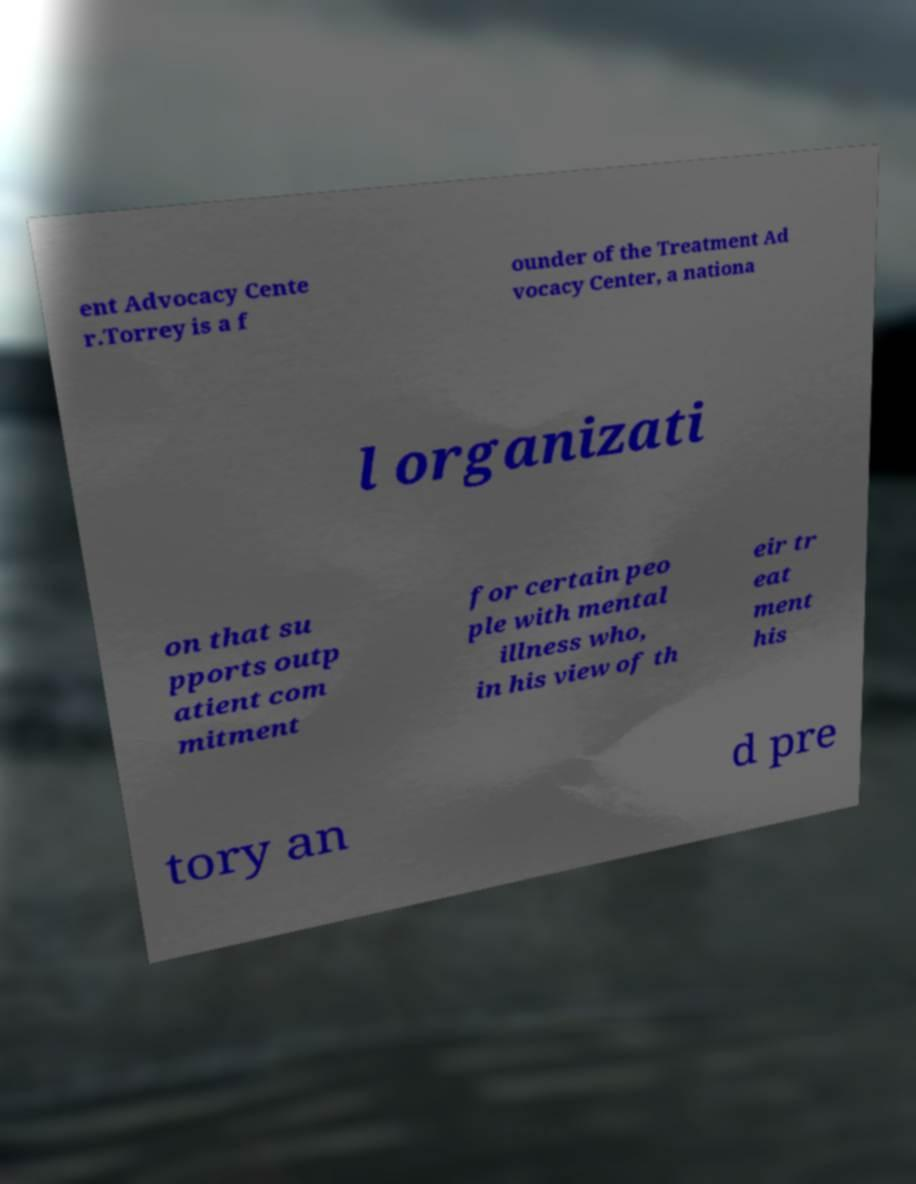Please read and relay the text visible in this image. What does it say? ent Advocacy Cente r.Torrey is a f ounder of the Treatment Ad vocacy Center, a nationa l organizati on that su pports outp atient com mitment for certain peo ple with mental illness who, in his view of th eir tr eat ment his tory an d pre 